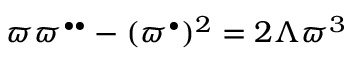<formula> <loc_0><loc_0><loc_500><loc_500>\varpi \varpi ^ { \bullet \bullet } - ( \varpi ^ { \bullet } ) ^ { 2 } = 2 \Lambda \varpi ^ { 3 }</formula> 